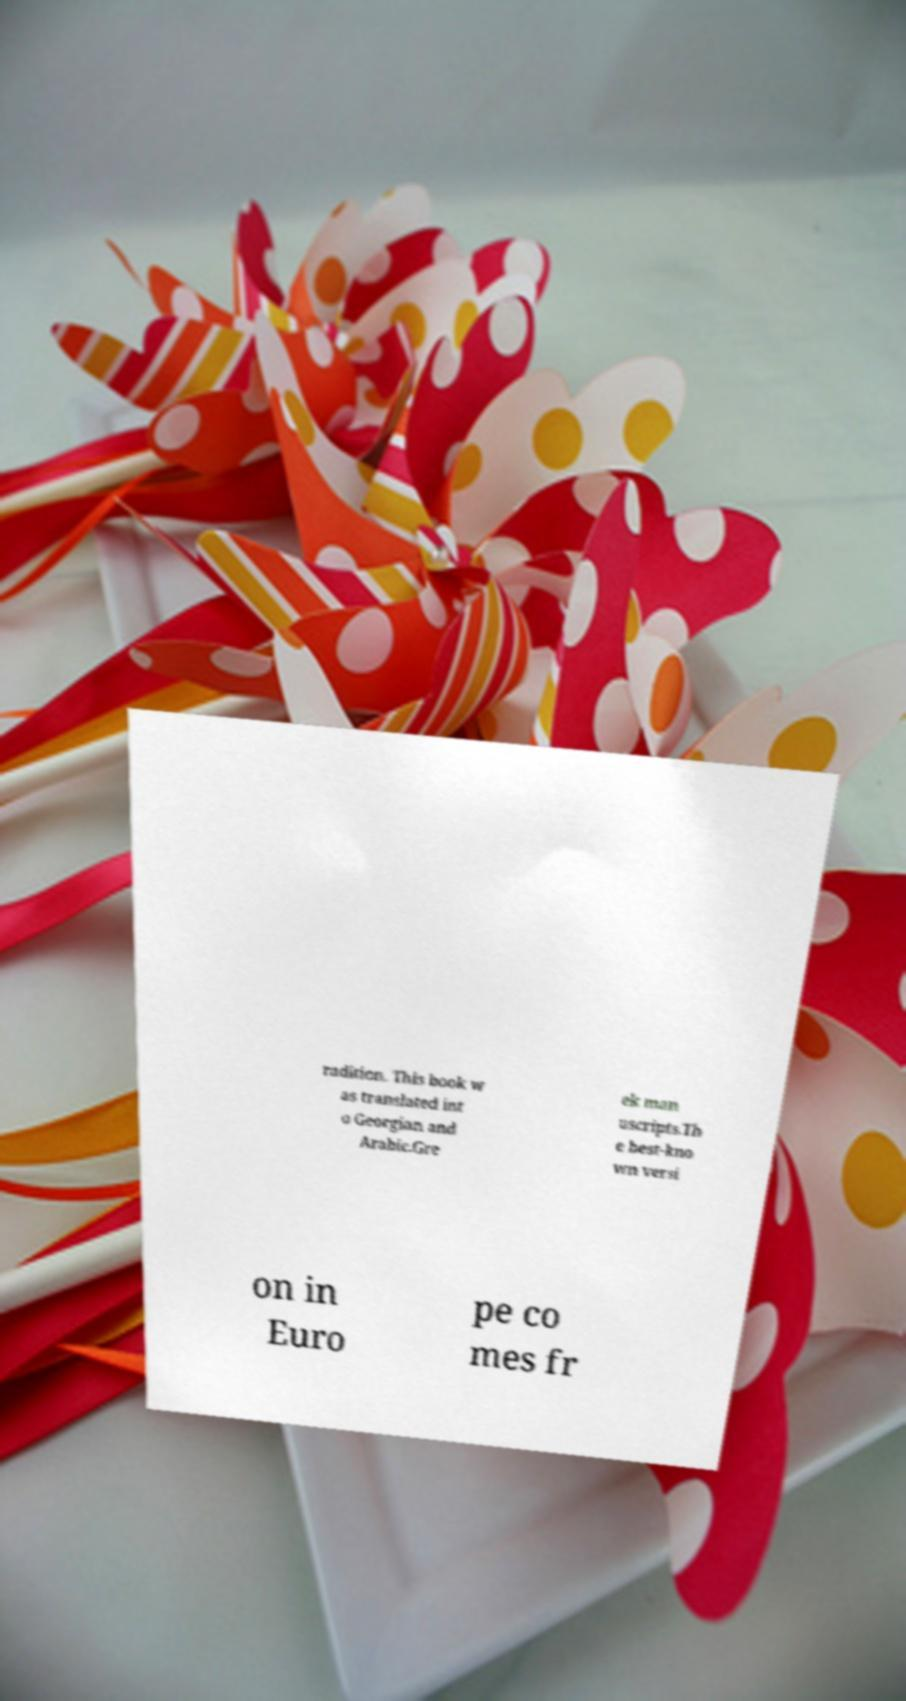Can you accurately transcribe the text from the provided image for me? radition. This book w as translated int o Georgian and Arabic.Gre ek man uscripts.Th e best-kno wn versi on in Euro pe co mes fr 